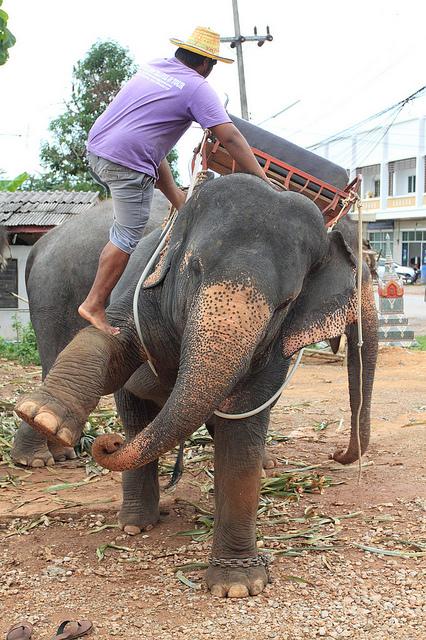How many elephants are in this picture?
Answer briefly. 1. How many people are riding?
Concise answer only. 1. Why is the elephant chained?
Quick response, please. Captivity. What color is the elephant's trunk?
Keep it brief. Gray. 